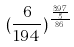<formula> <loc_0><loc_0><loc_500><loc_500>( \frac { 6 } { 1 9 4 } ) ^ { \frac { \frac { 3 9 7 } { 5 } } { 8 6 } }</formula> 